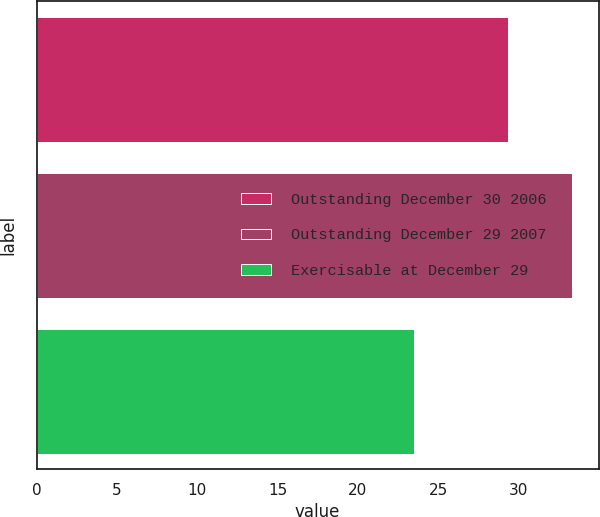<chart> <loc_0><loc_0><loc_500><loc_500><bar_chart><fcel>Outstanding December 30 2006<fcel>Outstanding December 29 2007<fcel>Exercisable at December 29<nl><fcel>29.32<fcel>33.31<fcel>23.5<nl></chart> 